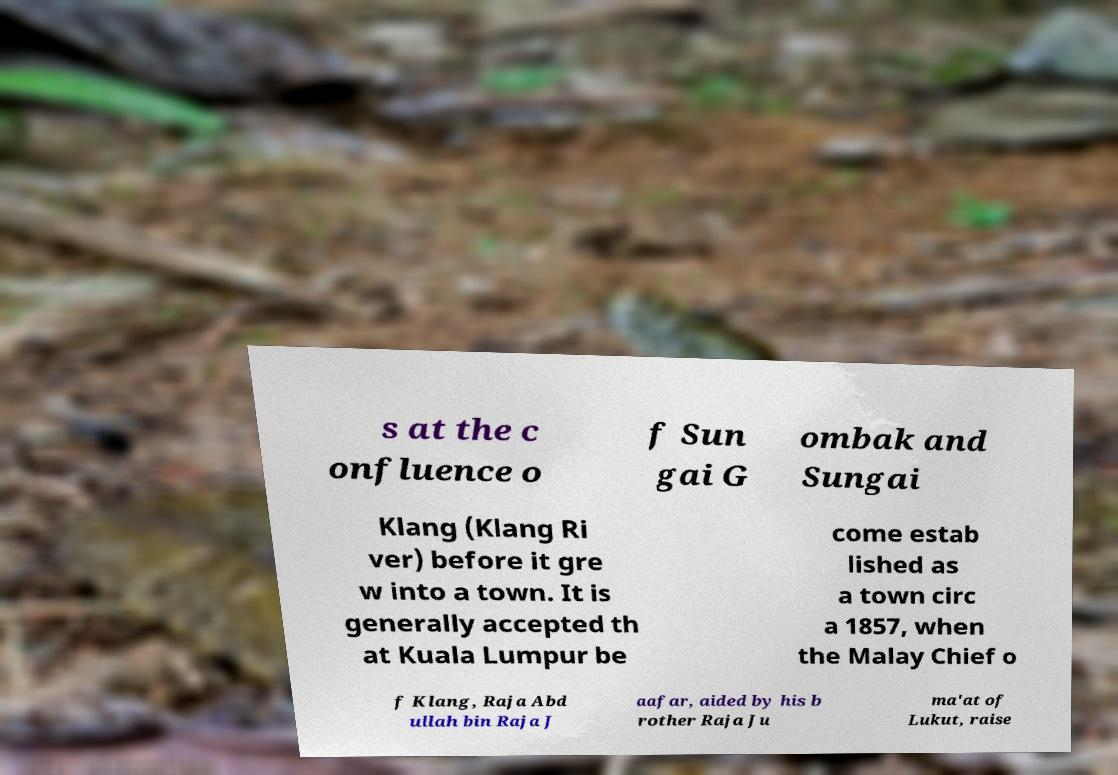Please read and relay the text visible in this image. What does it say? s at the c onfluence o f Sun gai G ombak and Sungai Klang (Klang Ri ver) before it gre w into a town. It is generally accepted th at Kuala Lumpur be come estab lished as a town circ a 1857, when the Malay Chief o f Klang, Raja Abd ullah bin Raja J aafar, aided by his b rother Raja Ju ma'at of Lukut, raise 